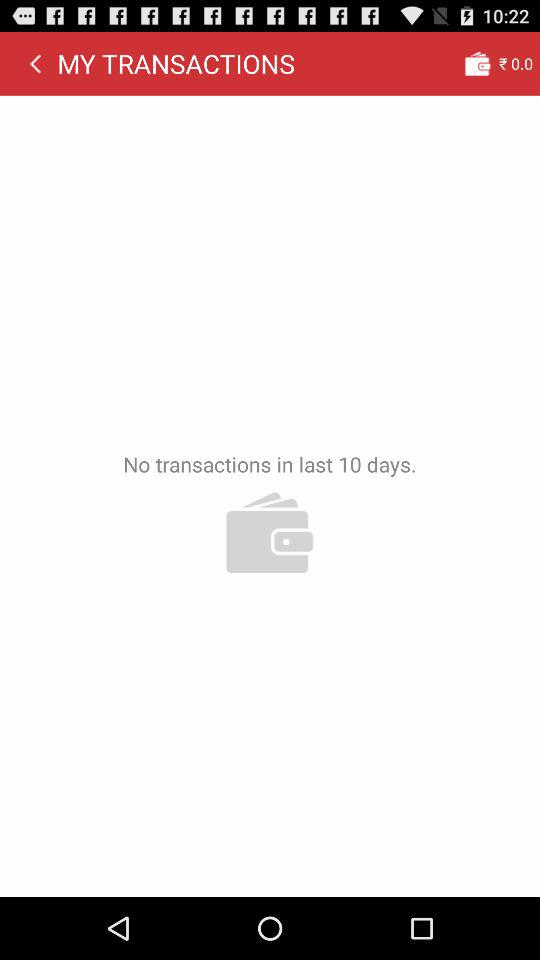What is the amount in the wallet? The amount in the wallet is ₹0. 